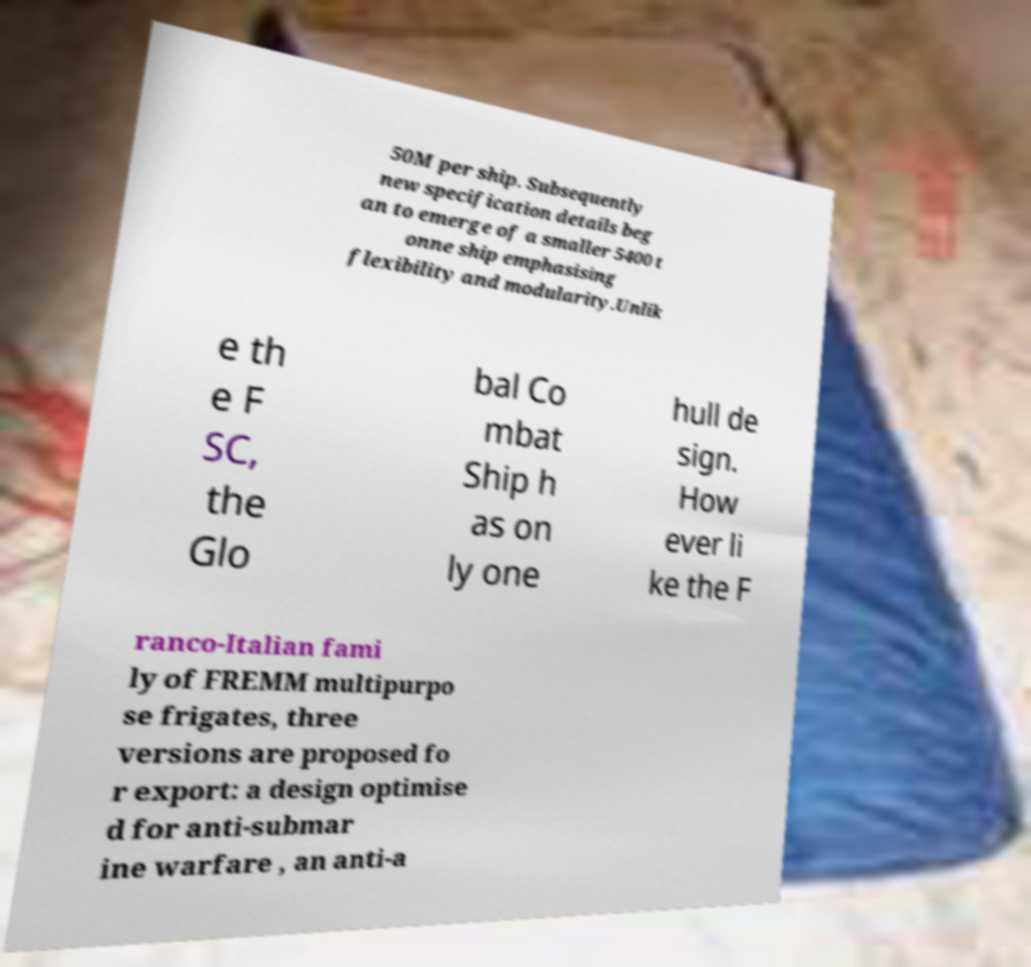Please read and relay the text visible in this image. What does it say? 50M per ship. Subsequently new specification details beg an to emerge of a smaller 5400 t onne ship emphasising flexibility and modularity.Unlik e th e F SC, the Glo bal Co mbat Ship h as on ly one hull de sign. How ever li ke the F ranco-Italian fami ly of FREMM multipurpo se frigates, three versions are proposed fo r export: a design optimise d for anti-submar ine warfare , an anti-a 